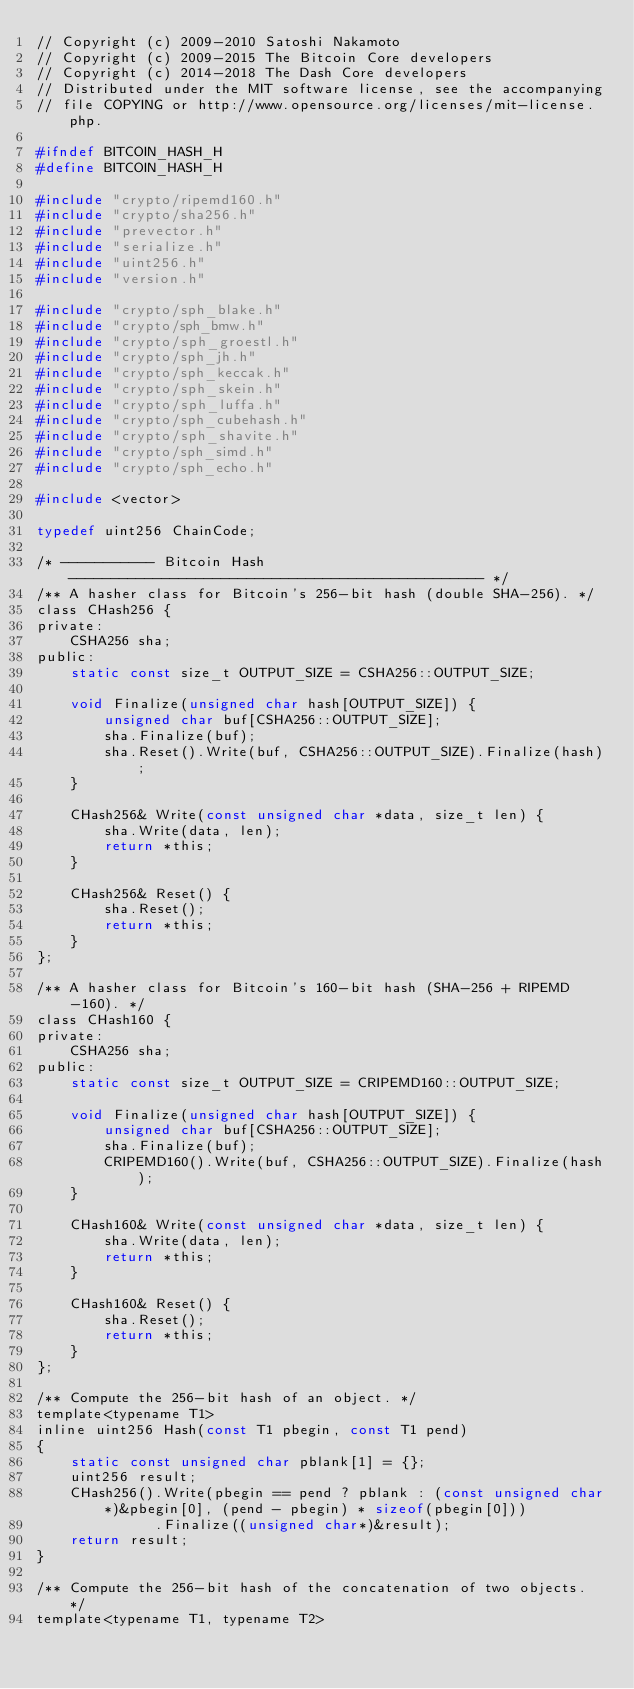<code> <loc_0><loc_0><loc_500><loc_500><_C_>// Copyright (c) 2009-2010 Satoshi Nakamoto
// Copyright (c) 2009-2015 The Bitcoin Core developers
// Copyright (c) 2014-2018 The Dash Core developers
// Distributed under the MIT software license, see the accompanying
// file COPYING or http://www.opensource.org/licenses/mit-license.php.

#ifndef BITCOIN_HASH_H
#define BITCOIN_HASH_H

#include "crypto/ripemd160.h"
#include "crypto/sha256.h"
#include "prevector.h"
#include "serialize.h"
#include "uint256.h"
#include "version.h"

#include "crypto/sph_blake.h"
#include "crypto/sph_bmw.h"
#include "crypto/sph_groestl.h"
#include "crypto/sph_jh.h"
#include "crypto/sph_keccak.h"
#include "crypto/sph_skein.h"
#include "crypto/sph_luffa.h"
#include "crypto/sph_cubehash.h"
#include "crypto/sph_shavite.h"
#include "crypto/sph_simd.h"
#include "crypto/sph_echo.h"

#include <vector>

typedef uint256 ChainCode;

/* ----------- Bitcoin Hash ------------------------------------------------- */
/** A hasher class for Bitcoin's 256-bit hash (double SHA-256). */
class CHash256 {
private:
    CSHA256 sha;
public:
    static const size_t OUTPUT_SIZE = CSHA256::OUTPUT_SIZE;

    void Finalize(unsigned char hash[OUTPUT_SIZE]) {
        unsigned char buf[CSHA256::OUTPUT_SIZE];
        sha.Finalize(buf);
        sha.Reset().Write(buf, CSHA256::OUTPUT_SIZE).Finalize(hash);
    }

    CHash256& Write(const unsigned char *data, size_t len) {
        sha.Write(data, len);
        return *this;
    }

    CHash256& Reset() {
        sha.Reset();
        return *this;
    }
};

/** A hasher class for Bitcoin's 160-bit hash (SHA-256 + RIPEMD-160). */
class CHash160 {
private:
    CSHA256 sha;
public:
    static const size_t OUTPUT_SIZE = CRIPEMD160::OUTPUT_SIZE;

    void Finalize(unsigned char hash[OUTPUT_SIZE]) {
        unsigned char buf[CSHA256::OUTPUT_SIZE];
        sha.Finalize(buf);
        CRIPEMD160().Write(buf, CSHA256::OUTPUT_SIZE).Finalize(hash);
    }

    CHash160& Write(const unsigned char *data, size_t len) {
        sha.Write(data, len);
        return *this;
    }

    CHash160& Reset() {
        sha.Reset();
        return *this;
    }
};

/** Compute the 256-bit hash of an object. */
template<typename T1>
inline uint256 Hash(const T1 pbegin, const T1 pend)
{
    static const unsigned char pblank[1] = {};
    uint256 result;
    CHash256().Write(pbegin == pend ? pblank : (const unsigned char*)&pbegin[0], (pend - pbegin) * sizeof(pbegin[0]))
              .Finalize((unsigned char*)&result);
    return result;
}

/** Compute the 256-bit hash of the concatenation of two objects. */
template<typename T1, typename T2></code> 